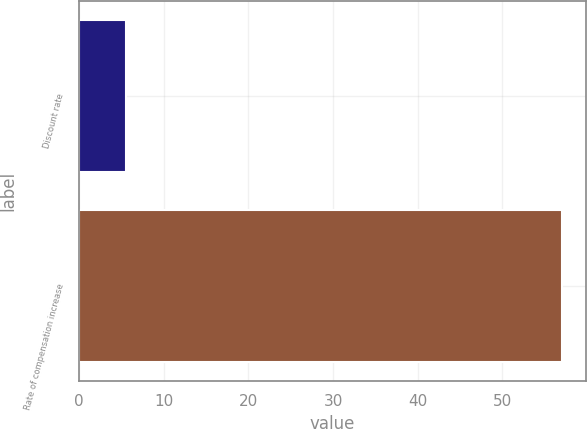Convert chart to OTSL. <chart><loc_0><loc_0><loc_500><loc_500><bar_chart><fcel>Discount rate<fcel>Rate of compensation increase<nl><fcel>5.5<fcel>57<nl></chart> 